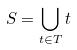Convert formula to latex. <formula><loc_0><loc_0><loc_500><loc_500>S = \bigcup _ { t \in T } t</formula> 